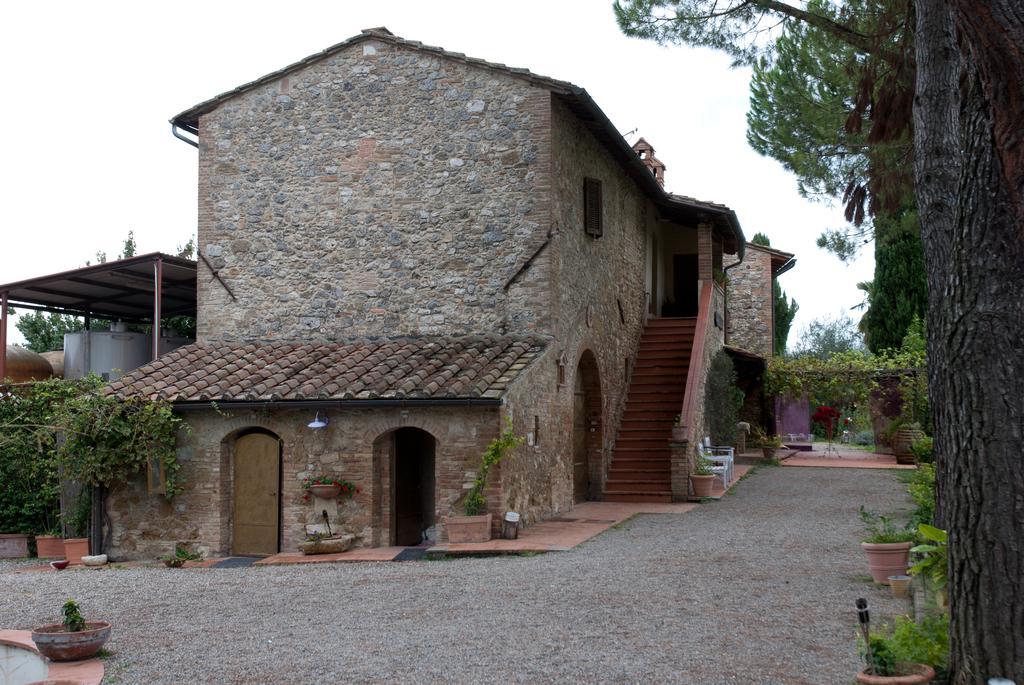Describe this image in one or two sentences. In this image we can see a building with doors, steps, windows and pillars. Also there are pots with plants. On the right side there are trees. In the background there is sky. Also there are creepers. 